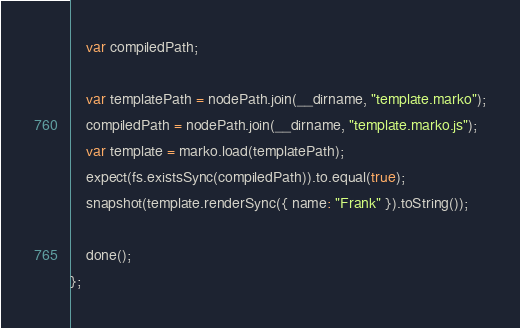Convert code to text. <code><loc_0><loc_0><loc_500><loc_500><_JavaScript_>
    var compiledPath;

    var templatePath = nodePath.join(__dirname, "template.marko");
    compiledPath = nodePath.join(__dirname, "template.marko.js");
    var template = marko.load(templatePath);
    expect(fs.existsSync(compiledPath)).to.equal(true);
    snapshot(template.renderSync({ name: "Frank" }).toString());

    done();
};
</code> 